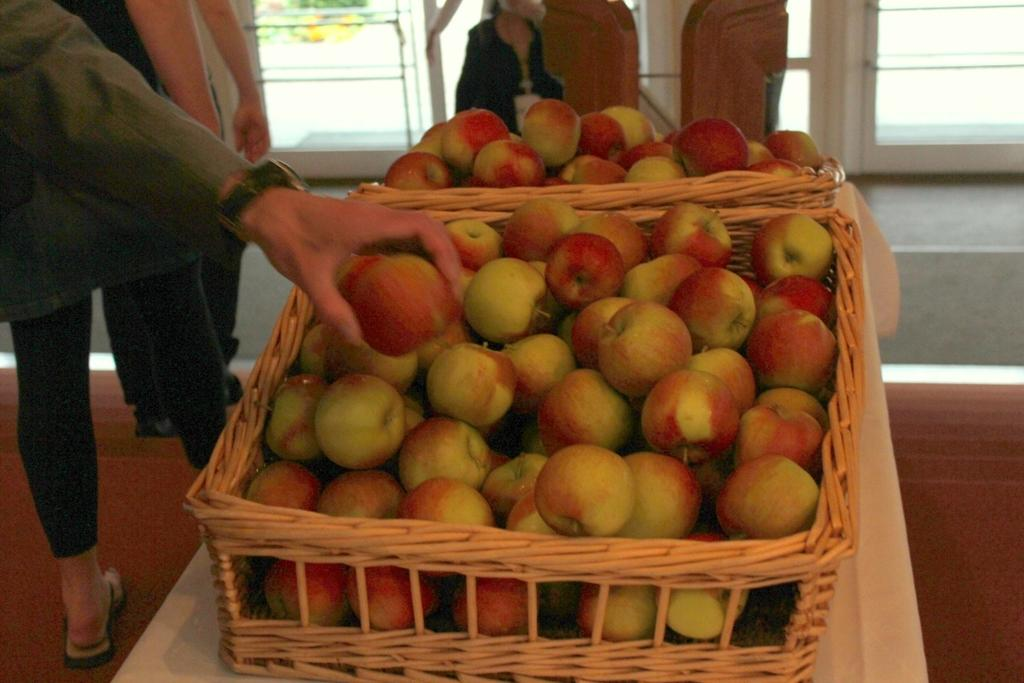What is located in the middle of the image? There is a basket in the middle of the image. What is inside the basket? The basket contains many apples. Who can be seen on the left side of the image? There are people on the left side of the image. Can you describe the background of the image? There is a person, windows, glass, and a floor visible in the background of the image. What type of joke can be seen in the drawer in the image? There is no drawer present in the image, and therefore no joke can be seen. 